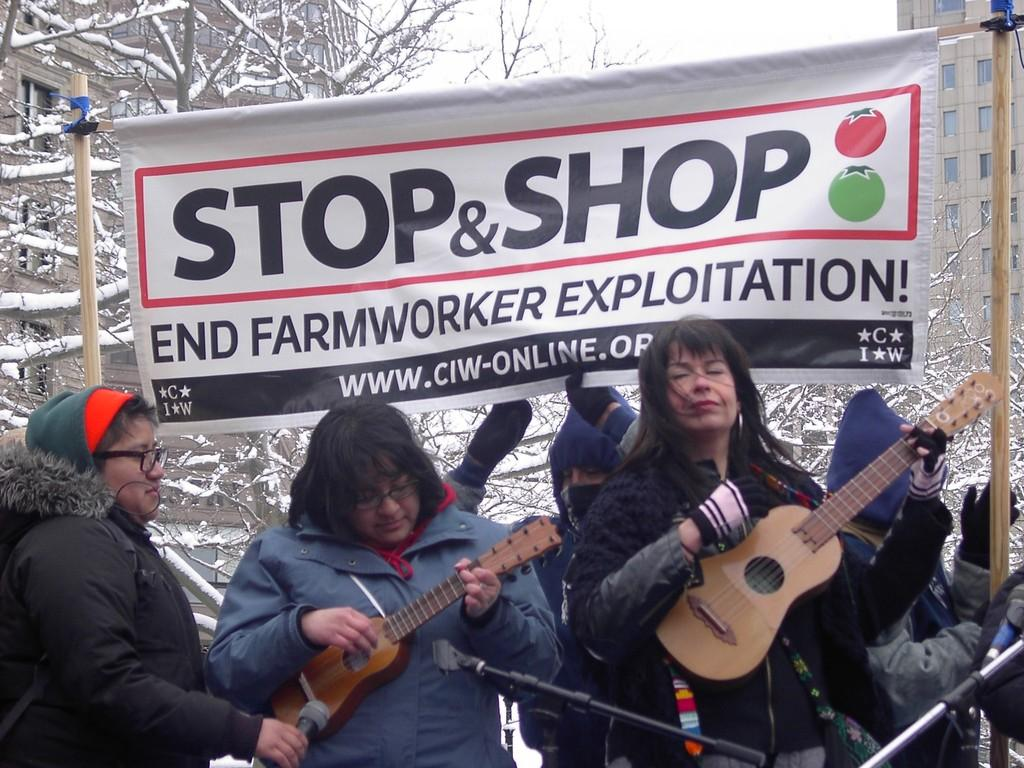How many people are in the image? There are three ladies in the image. What are two of the ladies holding? Two of the ladies are holding a guitar. What object is in front of the ladies? A microphone is in front of the ladies. What can be seen on the banner in the image? There is a banner with text in the image. What type of wren can be seen perched on the microphone in the image? There is no wren present in the image; it features three ladies, two of whom are holding guitars, a microphone, and a banner with text. 